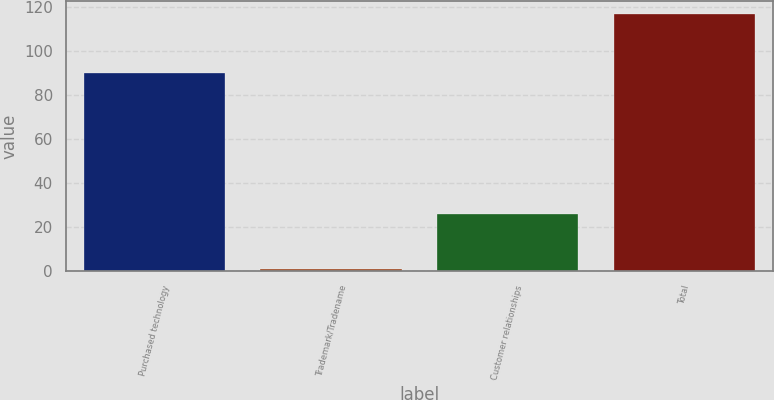<chart> <loc_0><loc_0><loc_500><loc_500><bar_chart><fcel>Purchased technology<fcel>Trademark/Tradename<fcel>Customer relationships<fcel>Total<nl><fcel>90<fcel>1<fcel>26<fcel>117<nl></chart> 